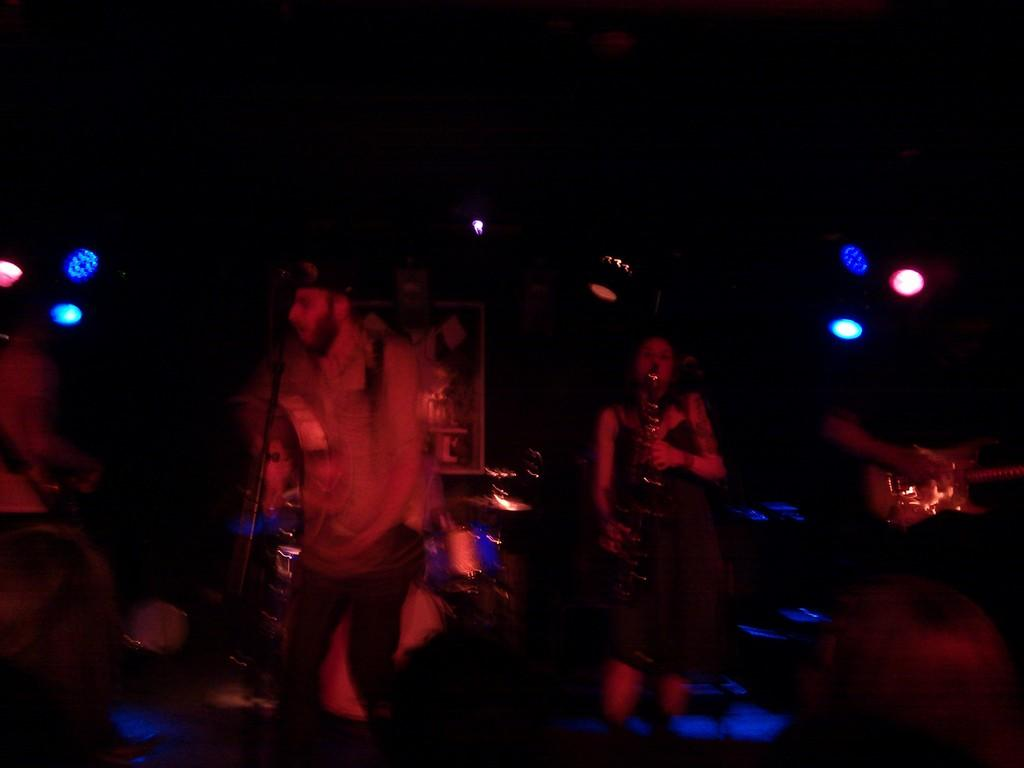What are the people in the image doing? The people in the image are holding musical instruments. What can be seen on a surface in the image? There are objects on a surface in the image. What can be seen in the background of the image? There are lights visible in the background of the image. What year is depicted in the image? The provided facts do not mention any specific year, so it cannot be determined from the image. What is the mass of the paste used in the image? There is no mention of paste in the image, so it cannot be determined. 